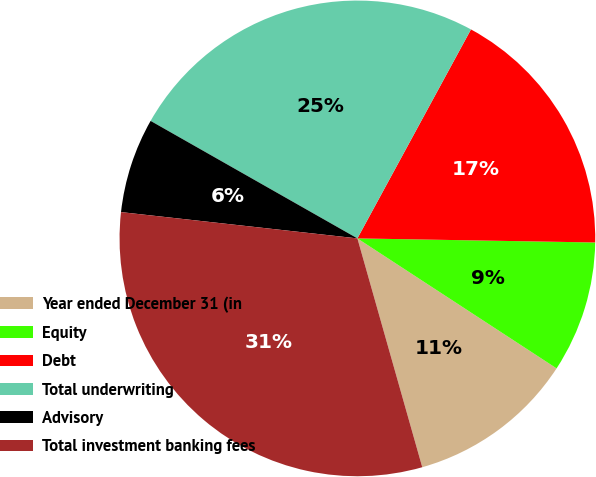Convert chart to OTSL. <chart><loc_0><loc_0><loc_500><loc_500><pie_chart><fcel>Year ended December 31 (in<fcel>Equity<fcel>Debt<fcel>Total underwriting<fcel>Advisory<fcel>Total investment banking fees<nl><fcel>11.4%<fcel>8.93%<fcel>17.35%<fcel>24.7%<fcel>6.46%<fcel>31.16%<nl></chart> 